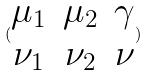Convert formula to latex. <formula><loc_0><loc_0><loc_500><loc_500>( \begin{matrix} \mu _ { 1 } & \mu _ { 2 } & \gamma \\ \nu _ { 1 } & \nu _ { 2 } & \nu \end{matrix} )</formula> 